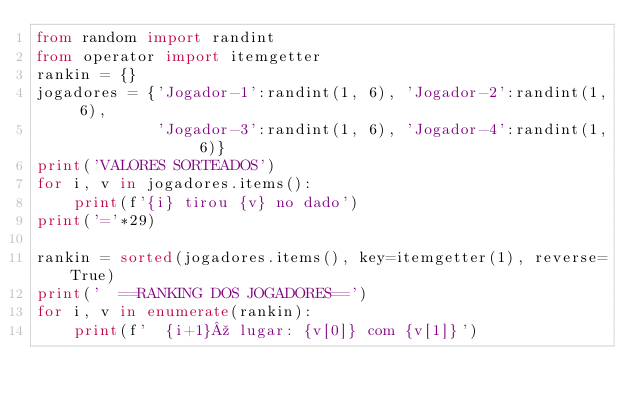<code> <loc_0><loc_0><loc_500><loc_500><_Python_>from random import randint
from operator import itemgetter
rankin = {}
jogadores = {'Jogador-1':randint(1, 6), 'Jogador-2':randint(1, 6),
             'Jogador-3':randint(1, 6), 'Jogador-4':randint(1, 6)}
print('VALORES SORTEADOS')
for i, v in jogadores.items():
    print(f'{i} tirou {v} no dado')
print('='*29)

rankin = sorted(jogadores.items(), key=itemgetter(1), reverse=True)
print('  ==RANKING DOS JOGADORES==')
for i, v in enumerate(rankin):
    print(f'  {i+1}º lugar: {v[0]} com {v[1]}')</code> 